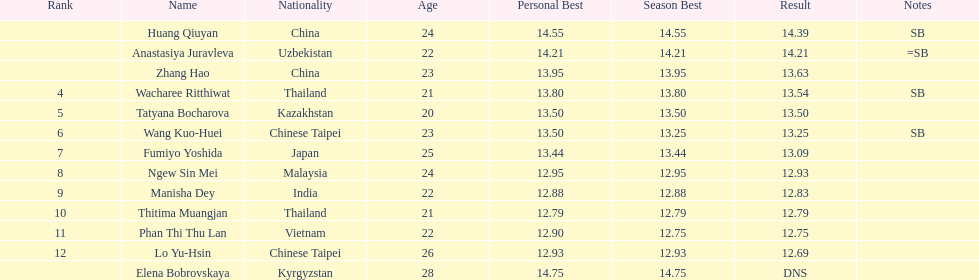What was the average result of the top three jumpers? 14.08. 